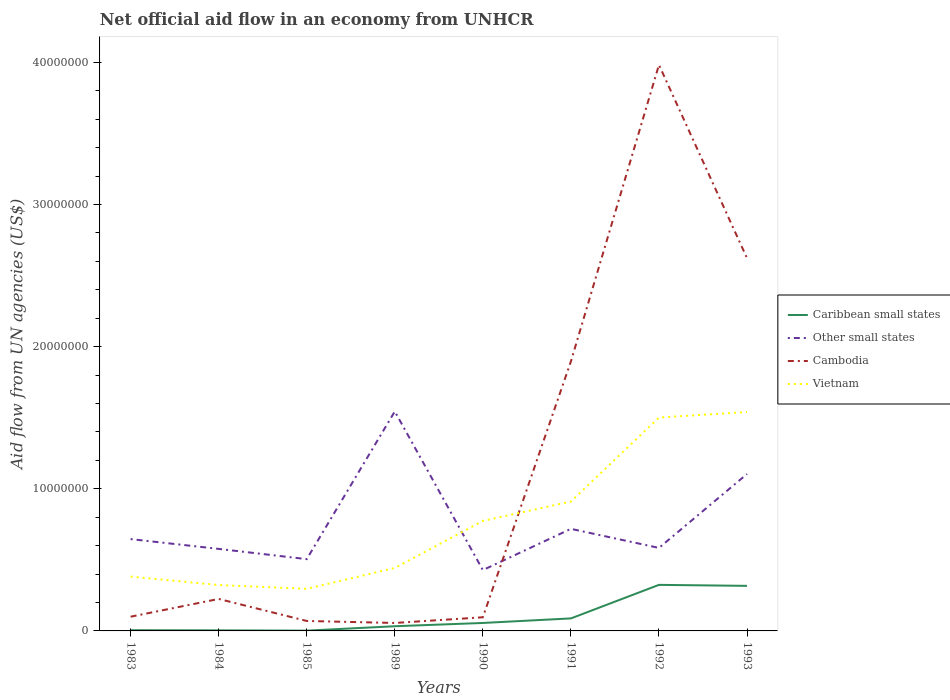In which year was the net official aid flow in Caribbean small states maximum?
Provide a short and direct response. 1985. What is the difference between the highest and the second highest net official aid flow in Vietnam?
Offer a very short reply. 1.24e+07. What is the difference between the highest and the lowest net official aid flow in Other small states?
Offer a very short reply. 2. Is the net official aid flow in Other small states strictly greater than the net official aid flow in Cambodia over the years?
Give a very brief answer. No. How many years are there in the graph?
Offer a terse response. 8. Does the graph contain grids?
Provide a succinct answer. No. What is the title of the graph?
Keep it short and to the point. Net official aid flow in an economy from UNHCR. What is the label or title of the X-axis?
Ensure brevity in your answer.  Years. What is the label or title of the Y-axis?
Offer a very short reply. Aid flow from UN agencies (US$). What is the Aid flow from UN agencies (US$) of Other small states in 1983?
Ensure brevity in your answer.  6.46e+06. What is the Aid flow from UN agencies (US$) in Vietnam in 1983?
Offer a terse response. 3.82e+06. What is the Aid flow from UN agencies (US$) in Other small states in 1984?
Keep it short and to the point. 5.77e+06. What is the Aid flow from UN agencies (US$) of Cambodia in 1984?
Make the answer very short. 2.25e+06. What is the Aid flow from UN agencies (US$) of Vietnam in 1984?
Make the answer very short. 3.23e+06. What is the Aid flow from UN agencies (US$) of Caribbean small states in 1985?
Your response must be concise. 2.00e+04. What is the Aid flow from UN agencies (US$) of Other small states in 1985?
Your answer should be compact. 5.05e+06. What is the Aid flow from UN agencies (US$) in Vietnam in 1985?
Make the answer very short. 2.96e+06. What is the Aid flow from UN agencies (US$) of Other small states in 1989?
Offer a terse response. 1.54e+07. What is the Aid flow from UN agencies (US$) of Cambodia in 1989?
Offer a terse response. 5.60e+05. What is the Aid flow from UN agencies (US$) of Vietnam in 1989?
Offer a terse response. 4.43e+06. What is the Aid flow from UN agencies (US$) of Caribbean small states in 1990?
Your response must be concise. 5.60e+05. What is the Aid flow from UN agencies (US$) in Other small states in 1990?
Keep it short and to the point. 4.28e+06. What is the Aid flow from UN agencies (US$) in Cambodia in 1990?
Offer a terse response. 9.60e+05. What is the Aid flow from UN agencies (US$) of Vietnam in 1990?
Offer a terse response. 7.74e+06. What is the Aid flow from UN agencies (US$) in Caribbean small states in 1991?
Provide a short and direct response. 8.80e+05. What is the Aid flow from UN agencies (US$) of Other small states in 1991?
Give a very brief answer. 7.18e+06. What is the Aid flow from UN agencies (US$) of Cambodia in 1991?
Ensure brevity in your answer.  1.90e+07. What is the Aid flow from UN agencies (US$) in Vietnam in 1991?
Provide a succinct answer. 9.10e+06. What is the Aid flow from UN agencies (US$) in Caribbean small states in 1992?
Offer a very short reply. 3.24e+06. What is the Aid flow from UN agencies (US$) in Other small states in 1992?
Your response must be concise. 5.84e+06. What is the Aid flow from UN agencies (US$) in Cambodia in 1992?
Your answer should be compact. 3.98e+07. What is the Aid flow from UN agencies (US$) in Vietnam in 1992?
Provide a short and direct response. 1.50e+07. What is the Aid flow from UN agencies (US$) in Caribbean small states in 1993?
Give a very brief answer. 3.17e+06. What is the Aid flow from UN agencies (US$) of Other small states in 1993?
Your answer should be very brief. 1.10e+07. What is the Aid flow from UN agencies (US$) in Cambodia in 1993?
Your answer should be very brief. 2.62e+07. What is the Aid flow from UN agencies (US$) in Vietnam in 1993?
Give a very brief answer. 1.54e+07. Across all years, what is the maximum Aid flow from UN agencies (US$) in Caribbean small states?
Provide a succinct answer. 3.24e+06. Across all years, what is the maximum Aid flow from UN agencies (US$) in Other small states?
Offer a terse response. 1.54e+07. Across all years, what is the maximum Aid flow from UN agencies (US$) of Cambodia?
Your response must be concise. 3.98e+07. Across all years, what is the maximum Aid flow from UN agencies (US$) of Vietnam?
Your response must be concise. 1.54e+07. Across all years, what is the minimum Aid flow from UN agencies (US$) in Other small states?
Your answer should be very brief. 4.28e+06. Across all years, what is the minimum Aid flow from UN agencies (US$) in Cambodia?
Make the answer very short. 5.60e+05. Across all years, what is the minimum Aid flow from UN agencies (US$) of Vietnam?
Offer a very short reply. 2.96e+06. What is the total Aid flow from UN agencies (US$) in Caribbean small states in the graph?
Your answer should be compact. 8.29e+06. What is the total Aid flow from UN agencies (US$) in Other small states in the graph?
Your answer should be very brief. 6.11e+07. What is the total Aid flow from UN agencies (US$) in Cambodia in the graph?
Offer a terse response. 9.05e+07. What is the total Aid flow from UN agencies (US$) in Vietnam in the graph?
Your answer should be very brief. 6.17e+07. What is the difference between the Aid flow from UN agencies (US$) in Caribbean small states in 1983 and that in 1984?
Your response must be concise. 10000. What is the difference between the Aid flow from UN agencies (US$) of Other small states in 1983 and that in 1984?
Ensure brevity in your answer.  6.90e+05. What is the difference between the Aid flow from UN agencies (US$) in Cambodia in 1983 and that in 1984?
Your answer should be compact. -1.25e+06. What is the difference between the Aid flow from UN agencies (US$) of Vietnam in 1983 and that in 1984?
Give a very brief answer. 5.90e+05. What is the difference between the Aid flow from UN agencies (US$) of Other small states in 1983 and that in 1985?
Your answer should be compact. 1.41e+06. What is the difference between the Aid flow from UN agencies (US$) of Cambodia in 1983 and that in 1985?
Offer a very short reply. 3.00e+05. What is the difference between the Aid flow from UN agencies (US$) in Vietnam in 1983 and that in 1985?
Offer a very short reply. 8.60e+05. What is the difference between the Aid flow from UN agencies (US$) of Caribbean small states in 1983 and that in 1989?
Make the answer very short. -2.80e+05. What is the difference between the Aid flow from UN agencies (US$) in Other small states in 1983 and that in 1989?
Provide a short and direct response. -8.98e+06. What is the difference between the Aid flow from UN agencies (US$) of Cambodia in 1983 and that in 1989?
Provide a short and direct response. 4.40e+05. What is the difference between the Aid flow from UN agencies (US$) in Vietnam in 1983 and that in 1989?
Offer a very short reply. -6.10e+05. What is the difference between the Aid flow from UN agencies (US$) of Caribbean small states in 1983 and that in 1990?
Keep it short and to the point. -5.10e+05. What is the difference between the Aid flow from UN agencies (US$) in Other small states in 1983 and that in 1990?
Provide a short and direct response. 2.18e+06. What is the difference between the Aid flow from UN agencies (US$) in Cambodia in 1983 and that in 1990?
Provide a succinct answer. 4.00e+04. What is the difference between the Aid flow from UN agencies (US$) of Vietnam in 1983 and that in 1990?
Ensure brevity in your answer.  -3.92e+06. What is the difference between the Aid flow from UN agencies (US$) in Caribbean small states in 1983 and that in 1991?
Your response must be concise. -8.30e+05. What is the difference between the Aid flow from UN agencies (US$) in Other small states in 1983 and that in 1991?
Offer a very short reply. -7.20e+05. What is the difference between the Aid flow from UN agencies (US$) of Cambodia in 1983 and that in 1991?
Provide a succinct answer. -1.80e+07. What is the difference between the Aid flow from UN agencies (US$) in Vietnam in 1983 and that in 1991?
Make the answer very short. -5.28e+06. What is the difference between the Aid flow from UN agencies (US$) of Caribbean small states in 1983 and that in 1992?
Provide a short and direct response. -3.19e+06. What is the difference between the Aid flow from UN agencies (US$) in Other small states in 1983 and that in 1992?
Ensure brevity in your answer.  6.20e+05. What is the difference between the Aid flow from UN agencies (US$) in Cambodia in 1983 and that in 1992?
Offer a terse response. -3.88e+07. What is the difference between the Aid flow from UN agencies (US$) in Vietnam in 1983 and that in 1992?
Keep it short and to the point. -1.12e+07. What is the difference between the Aid flow from UN agencies (US$) in Caribbean small states in 1983 and that in 1993?
Offer a very short reply. -3.12e+06. What is the difference between the Aid flow from UN agencies (US$) of Other small states in 1983 and that in 1993?
Make the answer very short. -4.58e+06. What is the difference between the Aid flow from UN agencies (US$) of Cambodia in 1983 and that in 1993?
Make the answer very short. -2.52e+07. What is the difference between the Aid flow from UN agencies (US$) in Vietnam in 1983 and that in 1993?
Give a very brief answer. -1.16e+07. What is the difference between the Aid flow from UN agencies (US$) in Caribbean small states in 1984 and that in 1985?
Offer a very short reply. 2.00e+04. What is the difference between the Aid flow from UN agencies (US$) in Other small states in 1984 and that in 1985?
Offer a very short reply. 7.20e+05. What is the difference between the Aid flow from UN agencies (US$) of Cambodia in 1984 and that in 1985?
Your answer should be very brief. 1.55e+06. What is the difference between the Aid flow from UN agencies (US$) in Caribbean small states in 1984 and that in 1989?
Offer a terse response. -2.90e+05. What is the difference between the Aid flow from UN agencies (US$) in Other small states in 1984 and that in 1989?
Ensure brevity in your answer.  -9.67e+06. What is the difference between the Aid flow from UN agencies (US$) in Cambodia in 1984 and that in 1989?
Make the answer very short. 1.69e+06. What is the difference between the Aid flow from UN agencies (US$) in Vietnam in 1984 and that in 1989?
Your response must be concise. -1.20e+06. What is the difference between the Aid flow from UN agencies (US$) in Caribbean small states in 1984 and that in 1990?
Keep it short and to the point. -5.20e+05. What is the difference between the Aid flow from UN agencies (US$) of Other small states in 1984 and that in 1990?
Your answer should be very brief. 1.49e+06. What is the difference between the Aid flow from UN agencies (US$) in Cambodia in 1984 and that in 1990?
Provide a succinct answer. 1.29e+06. What is the difference between the Aid flow from UN agencies (US$) of Vietnam in 1984 and that in 1990?
Your answer should be very brief. -4.51e+06. What is the difference between the Aid flow from UN agencies (US$) of Caribbean small states in 1984 and that in 1991?
Keep it short and to the point. -8.40e+05. What is the difference between the Aid flow from UN agencies (US$) in Other small states in 1984 and that in 1991?
Keep it short and to the point. -1.41e+06. What is the difference between the Aid flow from UN agencies (US$) of Cambodia in 1984 and that in 1991?
Your response must be concise. -1.67e+07. What is the difference between the Aid flow from UN agencies (US$) in Vietnam in 1984 and that in 1991?
Provide a succinct answer. -5.87e+06. What is the difference between the Aid flow from UN agencies (US$) of Caribbean small states in 1984 and that in 1992?
Your answer should be very brief. -3.20e+06. What is the difference between the Aid flow from UN agencies (US$) of Other small states in 1984 and that in 1992?
Your answer should be very brief. -7.00e+04. What is the difference between the Aid flow from UN agencies (US$) of Cambodia in 1984 and that in 1992?
Your answer should be very brief. -3.76e+07. What is the difference between the Aid flow from UN agencies (US$) of Vietnam in 1984 and that in 1992?
Offer a terse response. -1.18e+07. What is the difference between the Aid flow from UN agencies (US$) in Caribbean small states in 1984 and that in 1993?
Your answer should be compact. -3.13e+06. What is the difference between the Aid flow from UN agencies (US$) of Other small states in 1984 and that in 1993?
Keep it short and to the point. -5.27e+06. What is the difference between the Aid flow from UN agencies (US$) in Cambodia in 1984 and that in 1993?
Provide a short and direct response. -2.40e+07. What is the difference between the Aid flow from UN agencies (US$) of Vietnam in 1984 and that in 1993?
Give a very brief answer. -1.22e+07. What is the difference between the Aid flow from UN agencies (US$) in Caribbean small states in 1985 and that in 1989?
Provide a short and direct response. -3.10e+05. What is the difference between the Aid flow from UN agencies (US$) in Other small states in 1985 and that in 1989?
Provide a succinct answer. -1.04e+07. What is the difference between the Aid flow from UN agencies (US$) in Vietnam in 1985 and that in 1989?
Provide a short and direct response. -1.47e+06. What is the difference between the Aid flow from UN agencies (US$) of Caribbean small states in 1985 and that in 1990?
Give a very brief answer. -5.40e+05. What is the difference between the Aid flow from UN agencies (US$) in Other small states in 1985 and that in 1990?
Offer a terse response. 7.70e+05. What is the difference between the Aid flow from UN agencies (US$) in Cambodia in 1985 and that in 1990?
Keep it short and to the point. -2.60e+05. What is the difference between the Aid flow from UN agencies (US$) in Vietnam in 1985 and that in 1990?
Keep it short and to the point. -4.78e+06. What is the difference between the Aid flow from UN agencies (US$) in Caribbean small states in 1985 and that in 1991?
Your answer should be very brief. -8.60e+05. What is the difference between the Aid flow from UN agencies (US$) in Other small states in 1985 and that in 1991?
Your response must be concise. -2.13e+06. What is the difference between the Aid flow from UN agencies (US$) of Cambodia in 1985 and that in 1991?
Make the answer very short. -1.83e+07. What is the difference between the Aid flow from UN agencies (US$) in Vietnam in 1985 and that in 1991?
Your answer should be compact. -6.14e+06. What is the difference between the Aid flow from UN agencies (US$) in Caribbean small states in 1985 and that in 1992?
Provide a succinct answer. -3.22e+06. What is the difference between the Aid flow from UN agencies (US$) in Other small states in 1985 and that in 1992?
Keep it short and to the point. -7.90e+05. What is the difference between the Aid flow from UN agencies (US$) of Cambodia in 1985 and that in 1992?
Offer a very short reply. -3.91e+07. What is the difference between the Aid flow from UN agencies (US$) of Vietnam in 1985 and that in 1992?
Your response must be concise. -1.20e+07. What is the difference between the Aid flow from UN agencies (US$) of Caribbean small states in 1985 and that in 1993?
Make the answer very short. -3.15e+06. What is the difference between the Aid flow from UN agencies (US$) in Other small states in 1985 and that in 1993?
Provide a short and direct response. -5.99e+06. What is the difference between the Aid flow from UN agencies (US$) of Cambodia in 1985 and that in 1993?
Give a very brief answer. -2.55e+07. What is the difference between the Aid flow from UN agencies (US$) in Vietnam in 1985 and that in 1993?
Ensure brevity in your answer.  -1.24e+07. What is the difference between the Aid flow from UN agencies (US$) in Other small states in 1989 and that in 1990?
Make the answer very short. 1.12e+07. What is the difference between the Aid flow from UN agencies (US$) in Cambodia in 1989 and that in 1990?
Your answer should be compact. -4.00e+05. What is the difference between the Aid flow from UN agencies (US$) of Vietnam in 1989 and that in 1990?
Make the answer very short. -3.31e+06. What is the difference between the Aid flow from UN agencies (US$) in Caribbean small states in 1989 and that in 1991?
Your answer should be compact. -5.50e+05. What is the difference between the Aid flow from UN agencies (US$) in Other small states in 1989 and that in 1991?
Offer a terse response. 8.26e+06. What is the difference between the Aid flow from UN agencies (US$) in Cambodia in 1989 and that in 1991?
Keep it short and to the point. -1.84e+07. What is the difference between the Aid flow from UN agencies (US$) of Vietnam in 1989 and that in 1991?
Provide a succinct answer. -4.67e+06. What is the difference between the Aid flow from UN agencies (US$) of Caribbean small states in 1989 and that in 1992?
Ensure brevity in your answer.  -2.91e+06. What is the difference between the Aid flow from UN agencies (US$) in Other small states in 1989 and that in 1992?
Provide a succinct answer. 9.60e+06. What is the difference between the Aid flow from UN agencies (US$) of Cambodia in 1989 and that in 1992?
Offer a terse response. -3.93e+07. What is the difference between the Aid flow from UN agencies (US$) of Vietnam in 1989 and that in 1992?
Your response must be concise. -1.06e+07. What is the difference between the Aid flow from UN agencies (US$) in Caribbean small states in 1989 and that in 1993?
Make the answer very short. -2.84e+06. What is the difference between the Aid flow from UN agencies (US$) in Other small states in 1989 and that in 1993?
Keep it short and to the point. 4.40e+06. What is the difference between the Aid flow from UN agencies (US$) in Cambodia in 1989 and that in 1993?
Your response must be concise. -2.57e+07. What is the difference between the Aid flow from UN agencies (US$) in Vietnam in 1989 and that in 1993?
Keep it short and to the point. -1.10e+07. What is the difference between the Aid flow from UN agencies (US$) of Caribbean small states in 1990 and that in 1991?
Offer a terse response. -3.20e+05. What is the difference between the Aid flow from UN agencies (US$) in Other small states in 1990 and that in 1991?
Your answer should be compact. -2.90e+06. What is the difference between the Aid flow from UN agencies (US$) in Cambodia in 1990 and that in 1991?
Offer a terse response. -1.80e+07. What is the difference between the Aid flow from UN agencies (US$) in Vietnam in 1990 and that in 1991?
Provide a succinct answer. -1.36e+06. What is the difference between the Aid flow from UN agencies (US$) of Caribbean small states in 1990 and that in 1992?
Ensure brevity in your answer.  -2.68e+06. What is the difference between the Aid flow from UN agencies (US$) of Other small states in 1990 and that in 1992?
Ensure brevity in your answer.  -1.56e+06. What is the difference between the Aid flow from UN agencies (US$) in Cambodia in 1990 and that in 1992?
Make the answer very short. -3.89e+07. What is the difference between the Aid flow from UN agencies (US$) in Vietnam in 1990 and that in 1992?
Your answer should be compact. -7.27e+06. What is the difference between the Aid flow from UN agencies (US$) in Caribbean small states in 1990 and that in 1993?
Your answer should be very brief. -2.61e+06. What is the difference between the Aid flow from UN agencies (US$) in Other small states in 1990 and that in 1993?
Keep it short and to the point. -6.76e+06. What is the difference between the Aid flow from UN agencies (US$) of Cambodia in 1990 and that in 1993?
Offer a very short reply. -2.53e+07. What is the difference between the Aid flow from UN agencies (US$) of Vietnam in 1990 and that in 1993?
Keep it short and to the point. -7.66e+06. What is the difference between the Aid flow from UN agencies (US$) of Caribbean small states in 1991 and that in 1992?
Your answer should be very brief. -2.36e+06. What is the difference between the Aid flow from UN agencies (US$) of Other small states in 1991 and that in 1992?
Your answer should be very brief. 1.34e+06. What is the difference between the Aid flow from UN agencies (US$) of Cambodia in 1991 and that in 1992?
Offer a very short reply. -2.09e+07. What is the difference between the Aid flow from UN agencies (US$) of Vietnam in 1991 and that in 1992?
Provide a short and direct response. -5.91e+06. What is the difference between the Aid flow from UN agencies (US$) in Caribbean small states in 1991 and that in 1993?
Provide a succinct answer. -2.29e+06. What is the difference between the Aid flow from UN agencies (US$) in Other small states in 1991 and that in 1993?
Keep it short and to the point. -3.86e+06. What is the difference between the Aid flow from UN agencies (US$) in Cambodia in 1991 and that in 1993?
Provide a short and direct response. -7.26e+06. What is the difference between the Aid flow from UN agencies (US$) of Vietnam in 1991 and that in 1993?
Your answer should be compact. -6.30e+06. What is the difference between the Aid flow from UN agencies (US$) of Other small states in 1992 and that in 1993?
Make the answer very short. -5.20e+06. What is the difference between the Aid flow from UN agencies (US$) of Cambodia in 1992 and that in 1993?
Ensure brevity in your answer.  1.36e+07. What is the difference between the Aid flow from UN agencies (US$) in Vietnam in 1992 and that in 1993?
Make the answer very short. -3.90e+05. What is the difference between the Aid flow from UN agencies (US$) of Caribbean small states in 1983 and the Aid flow from UN agencies (US$) of Other small states in 1984?
Offer a very short reply. -5.72e+06. What is the difference between the Aid flow from UN agencies (US$) in Caribbean small states in 1983 and the Aid flow from UN agencies (US$) in Cambodia in 1984?
Give a very brief answer. -2.20e+06. What is the difference between the Aid flow from UN agencies (US$) of Caribbean small states in 1983 and the Aid flow from UN agencies (US$) of Vietnam in 1984?
Your answer should be compact. -3.18e+06. What is the difference between the Aid flow from UN agencies (US$) of Other small states in 1983 and the Aid flow from UN agencies (US$) of Cambodia in 1984?
Your answer should be compact. 4.21e+06. What is the difference between the Aid flow from UN agencies (US$) of Other small states in 1983 and the Aid flow from UN agencies (US$) of Vietnam in 1984?
Keep it short and to the point. 3.23e+06. What is the difference between the Aid flow from UN agencies (US$) in Cambodia in 1983 and the Aid flow from UN agencies (US$) in Vietnam in 1984?
Provide a succinct answer. -2.23e+06. What is the difference between the Aid flow from UN agencies (US$) in Caribbean small states in 1983 and the Aid flow from UN agencies (US$) in Other small states in 1985?
Your answer should be compact. -5.00e+06. What is the difference between the Aid flow from UN agencies (US$) of Caribbean small states in 1983 and the Aid flow from UN agencies (US$) of Cambodia in 1985?
Make the answer very short. -6.50e+05. What is the difference between the Aid flow from UN agencies (US$) in Caribbean small states in 1983 and the Aid flow from UN agencies (US$) in Vietnam in 1985?
Offer a very short reply. -2.91e+06. What is the difference between the Aid flow from UN agencies (US$) of Other small states in 1983 and the Aid flow from UN agencies (US$) of Cambodia in 1985?
Keep it short and to the point. 5.76e+06. What is the difference between the Aid flow from UN agencies (US$) of Other small states in 1983 and the Aid flow from UN agencies (US$) of Vietnam in 1985?
Ensure brevity in your answer.  3.50e+06. What is the difference between the Aid flow from UN agencies (US$) of Cambodia in 1983 and the Aid flow from UN agencies (US$) of Vietnam in 1985?
Offer a terse response. -1.96e+06. What is the difference between the Aid flow from UN agencies (US$) of Caribbean small states in 1983 and the Aid flow from UN agencies (US$) of Other small states in 1989?
Give a very brief answer. -1.54e+07. What is the difference between the Aid flow from UN agencies (US$) of Caribbean small states in 1983 and the Aid flow from UN agencies (US$) of Cambodia in 1989?
Make the answer very short. -5.10e+05. What is the difference between the Aid flow from UN agencies (US$) in Caribbean small states in 1983 and the Aid flow from UN agencies (US$) in Vietnam in 1989?
Make the answer very short. -4.38e+06. What is the difference between the Aid flow from UN agencies (US$) in Other small states in 1983 and the Aid flow from UN agencies (US$) in Cambodia in 1989?
Give a very brief answer. 5.90e+06. What is the difference between the Aid flow from UN agencies (US$) in Other small states in 1983 and the Aid flow from UN agencies (US$) in Vietnam in 1989?
Give a very brief answer. 2.03e+06. What is the difference between the Aid flow from UN agencies (US$) of Cambodia in 1983 and the Aid flow from UN agencies (US$) of Vietnam in 1989?
Make the answer very short. -3.43e+06. What is the difference between the Aid flow from UN agencies (US$) of Caribbean small states in 1983 and the Aid flow from UN agencies (US$) of Other small states in 1990?
Offer a terse response. -4.23e+06. What is the difference between the Aid flow from UN agencies (US$) in Caribbean small states in 1983 and the Aid flow from UN agencies (US$) in Cambodia in 1990?
Give a very brief answer. -9.10e+05. What is the difference between the Aid flow from UN agencies (US$) in Caribbean small states in 1983 and the Aid flow from UN agencies (US$) in Vietnam in 1990?
Your answer should be very brief. -7.69e+06. What is the difference between the Aid flow from UN agencies (US$) in Other small states in 1983 and the Aid flow from UN agencies (US$) in Cambodia in 1990?
Give a very brief answer. 5.50e+06. What is the difference between the Aid flow from UN agencies (US$) of Other small states in 1983 and the Aid flow from UN agencies (US$) of Vietnam in 1990?
Give a very brief answer. -1.28e+06. What is the difference between the Aid flow from UN agencies (US$) in Cambodia in 1983 and the Aid flow from UN agencies (US$) in Vietnam in 1990?
Your answer should be very brief. -6.74e+06. What is the difference between the Aid flow from UN agencies (US$) of Caribbean small states in 1983 and the Aid flow from UN agencies (US$) of Other small states in 1991?
Offer a very short reply. -7.13e+06. What is the difference between the Aid flow from UN agencies (US$) of Caribbean small states in 1983 and the Aid flow from UN agencies (US$) of Cambodia in 1991?
Your answer should be compact. -1.89e+07. What is the difference between the Aid flow from UN agencies (US$) in Caribbean small states in 1983 and the Aid flow from UN agencies (US$) in Vietnam in 1991?
Give a very brief answer. -9.05e+06. What is the difference between the Aid flow from UN agencies (US$) in Other small states in 1983 and the Aid flow from UN agencies (US$) in Cambodia in 1991?
Make the answer very short. -1.25e+07. What is the difference between the Aid flow from UN agencies (US$) of Other small states in 1983 and the Aid flow from UN agencies (US$) of Vietnam in 1991?
Give a very brief answer. -2.64e+06. What is the difference between the Aid flow from UN agencies (US$) in Cambodia in 1983 and the Aid flow from UN agencies (US$) in Vietnam in 1991?
Ensure brevity in your answer.  -8.10e+06. What is the difference between the Aid flow from UN agencies (US$) in Caribbean small states in 1983 and the Aid flow from UN agencies (US$) in Other small states in 1992?
Offer a terse response. -5.79e+06. What is the difference between the Aid flow from UN agencies (US$) of Caribbean small states in 1983 and the Aid flow from UN agencies (US$) of Cambodia in 1992?
Give a very brief answer. -3.98e+07. What is the difference between the Aid flow from UN agencies (US$) of Caribbean small states in 1983 and the Aid flow from UN agencies (US$) of Vietnam in 1992?
Your answer should be very brief. -1.50e+07. What is the difference between the Aid flow from UN agencies (US$) in Other small states in 1983 and the Aid flow from UN agencies (US$) in Cambodia in 1992?
Offer a very short reply. -3.34e+07. What is the difference between the Aid flow from UN agencies (US$) of Other small states in 1983 and the Aid flow from UN agencies (US$) of Vietnam in 1992?
Ensure brevity in your answer.  -8.55e+06. What is the difference between the Aid flow from UN agencies (US$) in Cambodia in 1983 and the Aid flow from UN agencies (US$) in Vietnam in 1992?
Provide a succinct answer. -1.40e+07. What is the difference between the Aid flow from UN agencies (US$) of Caribbean small states in 1983 and the Aid flow from UN agencies (US$) of Other small states in 1993?
Your answer should be compact. -1.10e+07. What is the difference between the Aid flow from UN agencies (US$) in Caribbean small states in 1983 and the Aid flow from UN agencies (US$) in Cambodia in 1993?
Your answer should be very brief. -2.62e+07. What is the difference between the Aid flow from UN agencies (US$) of Caribbean small states in 1983 and the Aid flow from UN agencies (US$) of Vietnam in 1993?
Make the answer very short. -1.54e+07. What is the difference between the Aid flow from UN agencies (US$) of Other small states in 1983 and the Aid flow from UN agencies (US$) of Cambodia in 1993?
Make the answer very short. -1.98e+07. What is the difference between the Aid flow from UN agencies (US$) in Other small states in 1983 and the Aid flow from UN agencies (US$) in Vietnam in 1993?
Your response must be concise. -8.94e+06. What is the difference between the Aid flow from UN agencies (US$) of Cambodia in 1983 and the Aid flow from UN agencies (US$) of Vietnam in 1993?
Ensure brevity in your answer.  -1.44e+07. What is the difference between the Aid flow from UN agencies (US$) of Caribbean small states in 1984 and the Aid flow from UN agencies (US$) of Other small states in 1985?
Give a very brief answer. -5.01e+06. What is the difference between the Aid flow from UN agencies (US$) of Caribbean small states in 1984 and the Aid flow from UN agencies (US$) of Cambodia in 1985?
Ensure brevity in your answer.  -6.60e+05. What is the difference between the Aid flow from UN agencies (US$) of Caribbean small states in 1984 and the Aid flow from UN agencies (US$) of Vietnam in 1985?
Make the answer very short. -2.92e+06. What is the difference between the Aid flow from UN agencies (US$) in Other small states in 1984 and the Aid flow from UN agencies (US$) in Cambodia in 1985?
Keep it short and to the point. 5.07e+06. What is the difference between the Aid flow from UN agencies (US$) of Other small states in 1984 and the Aid flow from UN agencies (US$) of Vietnam in 1985?
Make the answer very short. 2.81e+06. What is the difference between the Aid flow from UN agencies (US$) of Cambodia in 1984 and the Aid flow from UN agencies (US$) of Vietnam in 1985?
Make the answer very short. -7.10e+05. What is the difference between the Aid flow from UN agencies (US$) of Caribbean small states in 1984 and the Aid flow from UN agencies (US$) of Other small states in 1989?
Make the answer very short. -1.54e+07. What is the difference between the Aid flow from UN agencies (US$) of Caribbean small states in 1984 and the Aid flow from UN agencies (US$) of Cambodia in 1989?
Your response must be concise. -5.20e+05. What is the difference between the Aid flow from UN agencies (US$) of Caribbean small states in 1984 and the Aid flow from UN agencies (US$) of Vietnam in 1989?
Your answer should be compact. -4.39e+06. What is the difference between the Aid flow from UN agencies (US$) in Other small states in 1984 and the Aid flow from UN agencies (US$) in Cambodia in 1989?
Offer a terse response. 5.21e+06. What is the difference between the Aid flow from UN agencies (US$) in Other small states in 1984 and the Aid flow from UN agencies (US$) in Vietnam in 1989?
Ensure brevity in your answer.  1.34e+06. What is the difference between the Aid flow from UN agencies (US$) of Cambodia in 1984 and the Aid flow from UN agencies (US$) of Vietnam in 1989?
Provide a succinct answer. -2.18e+06. What is the difference between the Aid flow from UN agencies (US$) of Caribbean small states in 1984 and the Aid flow from UN agencies (US$) of Other small states in 1990?
Give a very brief answer. -4.24e+06. What is the difference between the Aid flow from UN agencies (US$) of Caribbean small states in 1984 and the Aid flow from UN agencies (US$) of Cambodia in 1990?
Provide a succinct answer. -9.20e+05. What is the difference between the Aid flow from UN agencies (US$) in Caribbean small states in 1984 and the Aid flow from UN agencies (US$) in Vietnam in 1990?
Your answer should be very brief. -7.70e+06. What is the difference between the Aid flow from UN agencies (US$) of Other small states in 1984 and the Aid flow from UN agencies (US$) of Cambodia in 1990?
Your answer should be very brief. 4.81e+06. What is the difference between the Aid flow from UN agencies (US$) of Other small states in 1984 and the Aid flow from UN agencies (US$) of Vietnam in 1990?
Your answer should be very brief. -1.97e+06. What is the difference between the Aid flow from UN agencies (US$) of Cambodia in 1984 and the Aid flow from UN agencies (US$) of Vietnam in 1990?
Offer a very short reply. -5.49e+06. What is the difference between the Aid flow from UN agencies (US$) of Caribbean small states in 1984 and the Aid flow from UN agencies (US$) of Other small states in 1991?
Give a very brief answer. -7.14e+06. What is the difference between the Aid flow from UN agencies (US$) in Caribbean small states in 1984 and the Aid flow from UN agencies (US$) in Cambodia in 1991?
Your answer should be compact. -1.89e+07. What is the difference between the Aid flow from UN agencies (US$) of Caribbean small states in 1984 and the Aid flow from UN agencies (US$) of Vietnam in 1991?
Ensure brevity in your answer.  -9.06e+06. What is the difference between the Aid flow from UN agencies (US$) of Other small states in 1984 and the Aid flow from UN agencies (US$) of Cambodia in 1991?
Provide a succinct answer. -1.32e+07. What is the difference between the Aid flow from UN agencies (US$) in Other small states in 1984 and the Aid flow from UN agencies (US$) in Vietnam in 1991?
Your response must be concise. -3.33e+06. What is the difference between the Aid flow from UN agencies (US$) in Cambodia in 1984 and the Aid flow from UN agencies (US$) in Vietnam in 1991?
Provide a succinct answer. -6.85e+06. What is the difference between the Aid flow from UN agencies (US$) of Caribbean small states in 1984 and the Aid flow from UN agencies (US$) of Other small states in 1992?
Your response must be concise. -5.80e+06. What is the difference between the Aid flow from UN agencies (US$) in Caribbean small states in 1984 and the Aid flow from UN agencies (US$) in Cambodia in 1992?
Your answer should be compact. -3.98e+07. What is the difference between the Aid flow from UN agencies (US$) in Caribbean small states in 1984 and the Aid flow from UN agencies (US$) in Vietnam in 1992?
Offer a terse response. -1.50e+07. What is the difference between the Aid flow from UN agencies (US$) of Other small states in 1984 and the Aid flow from UN agencies (US$) of Cambodia in 1992?
Your answer should be very brief. -3.40e+07. What is the difference between the Aid flow from UN agencies (US$) in Other small states in 1984 and the Aid flow from UN agencies (US$) in Vietnam in 1992?
Provide a succinct answer. -9.24e+06. What is the difference between the Aid flow from UN agencies (US$) of Cambodia in 1984 and the Aid flow from UN agencies (US$) of Vietnam in 1992?
Make the answer very short. -1.28e+07. What is the difference between the Aid flow from UN agencies (US$) of Caribbean small states in 1984 and the Aid flow from UN agencies (US$) of Other small states in 1993?
Provide a succinct answer. -1.10e+07. What is the difference between the Aid flow from UN agencies (US$) in Caribbean small states in 1984 and the Aid flow from UN agencies (US$) in Cambodia in 1993?
Your answer should be very brief. -2.62e+07. What is the difference between the Aid flow from UN agencies (US$) in Caribbean small states in 1984 and the Aid flow from UN agencies (US$) in Vietnam in 1993?
Ensure brevity in your answer.  -1.54e+07. What is the difference between the Aid flow from UN agencies (US$) in Other small states in 1984 and the Aid flow from UN agencies (US$) in Cambodia in 1993?
Provide a short and direct response. -2.04e+07. What is the difference between the Aid flow from UN agencies (US$) of Other small states in 1984 and the Aid flow from UN agencies (US$) of Vietnam in 1993?
Ensure brevity in your answer.  -9.63e+06. What is the difference between the Aid flow from UN agencies (US$) in Cambodia in 1984 and the Aid flow from UN agencies (US$) in Vietnam in 1993?
Keep it short and to the point. -1.32e+07. What is the difference between the Aid flow from UN agencies (US$) of Caribbean small states in 1985 and the Aid flow from UN agencies (US$) of Other small states in 1989?
Provide a succinct answer. -1.54e+07. What is the difference between the Aid flow from UN agencies (US$) of Caribbean small states in 1985 and the Aid flow from UN agencies (US$) of Cambodia in 1989?
Keep it short and to the point. -5.40e+05. What is the difference between the Aid flow from UN agencies (US$) of Caribbean small states in 1985 and the Aid flow from UN agencies (US$) of Vietnam in 1989?
Make the answer very short. -4.41e+06. What is the difference between the Aid flow from UN agencies (US$) of Other small states in 1985 and the Aid flow from UN agencies (US$) of Cambodia in 1989?
Make the answer very short. 4.49e+06. What is the difference between the Aid flow from UN agencies (US$) in Other small states in 1985 and the Aid flow from UN agencies (US$) in Vietnam in 1989?
Your answer should be very brief. 6.20e+05. What is the difference between the Aid flow from UN agencies (US$) in Cambodia in 1985 and the Aid flow from UN agencies (US$) in Vietnam in 1989?
Your answer should be very brief. -3.73e+06. What is the difference between the Aid flow from UN agencies (US$) of Caribbean small states in 1985 and the Aid flow from UN agencies (US$) of Other small states in 1990?
Your answer should be compact. -4.26e+06. What is the difference between the Aid flow from UN agencies (US$) in Caribbean small states in 1985 and the Aid flow from UN agencies (US$) in Cambodia in 1990?
Your answer should be very brief. -9.40e+05. What is the difference between the Aid flow from UN agencies (US$) in Caribbean small states in 1985 and the Aid flow from UN agencies (US$) in Vietnam in 1990?
Provide a succinct answer. -7.72e+06. What is the difference between the Aid flow from UN agencies (US$) of Other small states in 1985 and the Aid flow from UN agencies (US$) of Cambodia in 1990?
Provide a succinct answer. 4.09e+06. What is the difference between the Aid flow from UN agencies (US$) in Other small states in 1985 and the Aid flow from UN agencies (US$) in Vietnam in 1990?
Provide a succinct answer. -2.69e+06. What is the difference between the Aid flow from UN agencies (US$) of Cambodia in 1985 and the Aid flow from UN agencies (US$) of Vietnam in 1990?
Ensure brevity in your answer.  -7.04e+06. What is the difference between the Aid flow from UN agencies (US$) in Caribbean small states in 1985 and the Aid flow from UN agencies (US$) in Other small states in 1991?
Your response must be concise. -7.16e+06. What is the difference between the Aid flow from UN agencies (US$) of Caribbean small states in 1985 and the Aid flow from UN agencies (US$) of Cambodia in 1991?
Provide a short and direct response. -1.89e+07. What is the difference between the Aid flow from UN agencies (US$) in Caribbean small states in 1985 and the Aid flow from UN agencies (US$) in Vietnam in 1991?
Provide a succinct answer. -9.08e+06. What is the difference between the Aid flow from UN agencies (US$) of Other small states in 1985 and the Aid flow from UN agencies (US$) of Cambodia in 1991?
Ensure brevity in your answer.  -1.39e+07. What is the difference between the Aid flow from UN agencies (US$) in Other small states in 1985 and the Aid flow from UN agencies (US$) in Vietnam in 1991?
Your answer should be compact. -4.05e+06. What is the difference between the Aid flow from UN agencies (US$) in Cambodia in 1985 and the Aid flow from UN agencies (US$) in Vietnam in 1991?
Give a very brief answer. -8.40e+06. What is the difference between the Aid flow from UN agencies (US$) of Caribbean small states in 1985 and the Aid flow from UN agencies (US$) of Other small states in 1992?
Keep it short and to the point. -5.82e+06. What is the difference between the Aid flow from UN agencies (US$) of Caribbean small states in 1985 and the Aid flow from UN agencies (US$) of Cambodia in 1992?
Your answer should be very brief. -3.98e+07. What is the difference between the Aid flow from UN agencies (US$) of Caribbean small states in 1985 and the Aid flow from UN agencies (US$) of Vietnam in 1992?
Your answer should be very brief. -1.50e+07. What is the difference between the Aid flow from UN agencies (US$) in Other small states in 1985 and the Aid flow from UN agencies (US$) in Cambodia in 1992?
Offer a terse response. -3.48e+07. What is the difference between the Aid flow from UN agencies (US$) of Other small states in 1985 and the Aid flow from UN agencies (US$) of Vietnam in 1992?
Give a very brief answer. -9.96e+06. What is the difference between the Aid flow from UN agencies (US$) in Cambodia in 1985 and the Aid flow from UN agencies (US$) in Vietnam in 1992?
Your answer should be compact. -1.43e+07. What is the difference between the Aid flow from UN agencies (US$) of Caribbean small states in 1985 and the Aid flow from UN agencies (US$) of Other small states in 1993?
Offer a very short reply. -1.10e+07. What is the difference between the Aid flow from UN agencies (US$) of Caribbean small states in 1985 and the Aid flow from UN agencies (US$) of Cambodia in 1993?
Provide a short and direct response. -2.62e+07. What is the difference between the Aid flow from UN agencies (US$) in Caribbean small states in 1985 and the Aid flow from UN agencies (US$) in Vietnam in 1993?
Offer a terse response. -1.54e+07. What is the difference between the Aid flow from UN agencies (US$) of Other small states in 1985 and the Aid flow from UN agencies (US$) of Cambodia in 1993?
Your answer should be compact. -2.12e+07. What is the difference between the Aid flow from UN agencies (US$) in Other small states in 1985 and the Aid flow from UN agencies (US$) in Vietnam in 1993?
Your answer should be very brief. -1.04e+07. What is the difference between the Aid flow from UN agencies (US$) of Cambodia in 1985 and the Aid flow from UN agencies (US$) of Vietnam in 1993?
Your answer should be very brief. -1.47e+07. What is the difference between the Aid flow from UN agencies (US$) of Caribbean small states in 1989 and the Aid flow from UN agencies (US$) of Other small states in 1990?
Keep it short and to the point. -3.95e+06. What is the difference between the Aid flow from UN agencies (US$) of Caribbean small states in 1989 and the Aid flow from UN agencies (US$) of Cambodia in 1990?
Provide a succinct answer. -6.30e+05. What is the difference between the Aid flow from UN agencies (US$) of Caribbean small states in 1989 and the Aid flow from UN agencies (US$) of Vietnam in 1990?
Your answer should be compact. -7.41e+06. What is the difference between the Aid flow from UN agencies (US$) in Other small states in 1989 and the Aid flow from UN agencies (US$) in Cambodia in 1990?
Keep it short and to the point. 1.45e+07. What is the difference between the Aid flow from UN agencies (US$) in Other small states in 1989 and the Aid flow from UN agencies (US$) in Vietnam in 1990?
Give a very brief answer. 7.70e+06. What is the difference between the Aid flow from UN agencies (US$) of Cambodia in 1989 and the Aid flow from UN agencies (US$) of Vietnam in 1990?
Provide a succinct answer. -7.18e+06. What is the difference between the Aid flow from UN agencies (US$) of Caribbean small states in 1989 and the Aid flow from UN agencies (US$) of Other small states in 1991?
Provide a short and direct response. -6.85e+06. What is the difference between the Aid flow from UN agencies (US$) of Caribbean small states in 1989 and the Aid flow from UN agencies (US$) of Cambodia in 1991?
Give a very brief answer. -1.86e+07. What is the difference between the Aid flow from UN agencies (US$) of Caribbean small states in 1989 and the Aid flow from UN agencies (US$) of Vietnam in 1991?
Keep it short and to the point. -8.77e+06. What is the difference between the Aid flow from UN agencies (US$) of Other small states in 1989 and the Aid flow from UN agencies (US$) of Cambodia in 1991?
Your answer should be very brief. -3.52e+06. What is the difference between the Aid flow from UN agencies (US$) in Other small states in 1989 and the Aid flow from UN agencies (US$) in Vietnam in 1991?
Your response must be concise. 6.34e+06. What is the difference between the Aid flow from UN agencies (US$) of Cambodia in 1989 and the Aid flow from UN agencies (US$) of Vietnam in 1991?
Ensure brevity in your answer.  -8.54e+06. What is the difference between the Aid flow from UN agencies (US$) in Caribbean small states in 1989 and the Aid flow from UN agencies (US$) in Other small states in 1992?
Provide a short and direct response. -5.51e+06. What is the difference between the Aid flow from UN agencies (US$) of Caribbean small states in 1989 and the Aid flow from UN agencies (US$) of Cambodia in 1992?
Keep it short and to the point. -3.95e+07. What is the difference between the Aid flow from UN agencies (US$) in Caribbean small states in 1989 and the Aid flow from UN agencies (US$) in Vietnam in 1992?
Offer a very short reply. -1.47e+07. What is the difference between the Aid flow from UN agencies (US$) in Other small states in 1989 and the Aid flow from UN agencies (US$) in Cambodia in 1992?
Your answer should be compact. -2.44e+07. What is the difference between the Aid flow from UN agencies (US$) of Cambodia in 1989 and the Aid flow from UN agencies (US$) of Vietnam in 1992?
Your answer should be very brief. -1.44e+07. What is the difference between the Aid flow from UN agencies (US$) of Caribbean small states in 1989 and the Aid flow from UN agencies (US$) of Other small states in 1993?
Your answer should be compact. -1.07e+07. What is the difference between the Aid flow from UN agencies (US$) in Caribbean small states in 1989 and the Aid flow from UN agencies (US$) in Cambodia in 1993?
Your answer should be compact. -2.59e+07. What is the difference between the Aid flow from UN agencies (US$) in Caribbean small states in 1989 and the Aid flow from UN agencies (US$) in Vietnam in 1993?
Give a very brief answer. -1.51e+07. What is the difference between the Aid flow from UN agencies (US$) in Other small states in 1989 and the Aid flow from UN agencies (US$) in Cambodia in 1993?
Your answer should be very brief. -1.08e+07. What is the difference between the Aid flow from UN agencies (US$) in Cambodia in 1989 and the Aid flow from UN agencies (US$) in Vietnam in 1993?
Provide a succinct answer. -1.48e+07. What is the difference between the Aid flow from UN agencies (US$) of Caribbean small states in 1990 and the Aid flow from UN agencies (US$) of Other small states in 1991?
Your response must be concise. -6.62e+06. What is the difference between the Aid flow from UN agencies (US$) in Caribbean small states in 1990 and the Aid flow from UN agencies (US$) in Cambodia in 1991?
Keep it short and to the point. -1.84e+07. What is the difference between the Aid flow from UN agencies (US$) in Caribbean small states in 1990 and the Aid flow from UN agencies (US$) in Vietnam in 1991?
Offer a terse response. -8.54e+06. What is the difference between the Aid flow from UN agencies (US$) in Other small states in 1990 and the Aid flow from UN agencies (US$) in Cambodia in 1991?
Give a very brief answer. -1.47e+07. What is the difference between the Aid flow from UN agencies (US$) of Other small states in 1990 and the Aid flow from UN agencies (US$) of Vietnam in 1991?
Offer a terse response. -4.82e+06. What is the difference between the Aid flow from UN agencies (US$) of Cambodia in 1990 and the Aid flow from UN agencies (US$) of Vietnam in 1991?
Give a very brief answer. -8.14e+06. What is the difference between the Aid flow from UN agencies (US$) of Caribbean small states in 1990 and the Aid flow from UN agencies (US$) of Other small states in 1992?
Offer a very short reply. -5.28e+06. What is the difference between the Aid flow from UN agencies (US$) in Caribbean small states in 1990 and the Aid flow from UN agencies (US$) in Cambodia in 1992?
Your response must be concise. -3.93e+07. What is the difference between the Aid flow from UN agencies (US$) of Caribbean small states in 1990 and the Aid flow from UN agencies (US$) of Vietnam in 1992?
Your answer should be compact. -1.44e+07. What is the difference between the Aid flow from UN agencies (US$) of Other small states in 1990 and the Aid flow from UN agencies (US$) of Cambodia in 1992?
Keep it short and to the point. -3.55e+07. What is the difference between the Aid flow from UN agencies (US$) in Other small states in 1990 and the Aid flow from UN agencies (US$) in Vietnam in 1992?
Your response must be concise. -1.07e+07. What is the difference between the Aid flow from UN agencies (US$) in Cambodia in 1990 and the Aid flow from UN agencies (US$) in Vietnam in 1992?
Give a very brief answer. -1.40e+07. What is the difference between the Aid flow from UN agencies (US$) in Caribbean small states in 1990 and the Aid flow from UN agencies (US$) in Other small states in 1993?
Make the answer very short. -1.05e+07. What is the difference between the Aid flow from UN agencies (US$) of Caribbean small states in 1990 and the Aid flow from UN agencies (US$) of Cambodia in 1993?
Offer a terse response. -2.57e+07. What is the difference between the Aid flow from UN agencies (US$) of Caribbean small states in 1990 and the Aid flow from UN agencies (US$) of Vietnam in 1993?
Make the answer very short. -1.48e+07. What is the difference between the Aid flow from UN agencies (US$) of Other small states in 1990 and the Aid flow from UN agencies (US$) of Cambodia in 1993?
Your answer should be compact. -2.19e+07. What is the difference between the Aid flow from UN agencies (US$) of Other small states in 1990 and the Aid flow from UN agencies (US$) of Vietnam in 1993?
Provide a short and direct response. -1.11e+07. What is the difference between the Aid flow from UN agencies (US$) of Cambodia in 1990 and the Aid flow from UN agencies (US$) of Vietnam in 1993?
Your response must be concise. -1.44e+07. What is the difference between the Aid flow from UN agencies (US$) of Caribbean small states in 1991 and the Aid flow from UN agencies (US$) of Other small states in 1992?
Offer a terse response. -4.96e+06. What is the difference between the Aid flow from UN agencies (US$) of Caribbean small states in 1991 and the Aid flow from UN agencies (US$) of Cambodia in 1992?
Make the answer very short. -3.89e+07. What is the difference between the Aid flow from UN agencies (US$) of Caribbean small states in 1991 and the Aid flow from UN agencies (US$) of Vietnam in 1992?
Ensure brevity in your answer.  -1.41e+07. What is the difference between the Aid flow from UN agencies (US$) in Other small states in 1991 and the Aid flow from UN agencies (US$) in Cambodia in 1992?
Your answer should be very brief. -3.26e+07. What is the difference between the Aid flow from UN agencies (US$) in Other small states in 1991 and the Aid flow from UN agencies (US$) in Vietnam in 1992?
Make the answer very short. -7.83e+06. What is the difference between the Aid flow from UN agencies (US$) in Cambodia in 1991 and the Aid flow from UN agencies (US$) in Vietnam in 1992?
Your answer should be very brief. 3.95e+06. What is the difference between the Aid flow from UN agencies (US$) in Caribbean small states in 1991 and the Aid flow from UN agencies (US$) in Other small states in 1993?
Your response must be concise. -1.02e+07. What is the difference between the Aid flow from UN agencies (US$) in Caribbean small states in 1991 and the Aid flow from UN agencies (US$) in Cambodia in 1993?
Provide a succinct answer. -2.53e+07. What is the difference between the Aid flow from UN agencies (US$) in Caribbean small states in 1991 and the Aid flow from UN agencies (US$) in Vietnam in 1993?
Provide a succinct answer. -1.45e+07. What is the difference between the Aid flow from UN agencies (US$) of Other small states in 1991 and the Aid flow from UN agencies (US$) of Cambodia in 1993?
Provide a succinct answer. -1.90e+07. What is the difference between the Aid flow from UN agencies (US$) in Other small states in 1991 and the Aid flow from UN agencies (US$) in Vietnam in 1993?
Provide a short and direct response. -8.22e+06. What is the difference between the Aid flow from UN agencies (US$) in Cambodia in 1991 and the Aid flow from UN agencies (US$) in Vietnam in 1993?
Keep it short and to the point. 3.56e+06. What is the difference between the Aid flow from UN agencies (US$) of Caribbean small states in 1992 and the Aid flow from UN agencies (US$) of Other small states in 1993?
Ensure brevity in your answer.  -7.80e+06. What is the difference between the Aid flow from UN agencies (US$) of Caribbean small states in 1992 and the Aid flow from UN agencies (US$) of Cambodia in 1993?
Your answer should be compact. -2.30e+07. What is the difference between the Aid flow from UN agencies (US$) of Caribbean small states in 1992 and the Aid flow from UN agencies (US$) of Vietnam in 1993?
Your response must be concise. -1.22e+07. What is the difference between the Aid flow from UN agencies (US$) of Other small states in 1992 and the Aid flow from UN agencies (US$) of Cambodia in 1993?
Give a very brief answer. -2.04e+07. What is the difference between the Aid flow from UN agencies (US$) of Other small states in 1992 and the Aid flow from UN agencies (US$) of Vietnam in 1993?
Make the answer very short. -9.56e+06. What is the difference between the Aid flow from UN agencies (US$) in Cambodia in 1992 and the Aid flow from UN agencies (US$) in Vietnam in 1993?
Ensure brevity in your answer.  2.44e+07. What is the average Aid flow from UN agencies (US$) in Caribbean small states per year?
Give a very brief answer. 1.04e+06. What is the average Aid flow from UN agencies (US$) in Other small states per year?
Keep it short and to the point. 7.63e+06. What is the average Aid flow from UN agencies (US$) of Cambodia per year?
Give a very brief answer. 1.13e+07. What is the average Aid flow from UN agencies (US$) in Vietnam per year?
Keep it short and to the point. 7.71e+06. In the year 1983, what is the difference between the Aid flow from UN agencies (US$) in Caribbean small states and Aid flow from UN agencies (US$) in Other small states?
Offer a terse response. -6.41e+06. In the year 1983, what is the difference between the Aid flow from UN agencies (US$) of Caribbean small states and Aid flow from UN agencies (US$) of Cambodia?
Give a very brief answer. -9.50e+05. In the year 1983, what is the difference between the Aid flow from UN agencies (US$) in Caribbean small states and Aid flow from UN agencies (US$) in Vietnam?
Your answer should be compact. -3.77e+06. In the year 1983, what is the difference between the Aid flow from UN agencies (US$) in Other small states and Aid flow from UN agencies (US$) in Cambodia?
Keep it short and to the point. 5.46e+06. In the year 1983, what is the difference between the Aid flow from UN agencies (US$) in Other small states and Aid flow from UN agencies (US$) in Vietnam?
Your answer should be very brief. 2.64e+06. In the year 1983, what is the difference between the Aid flow from UN agencies (US$) in Cambodia and Aid flow from UN agencies (US$) in Vietnam?
Make the answer very short. -2.82e+06. In the year 1984, what is the difference between the Aid flow from UN agencies (US$) in Caribbean small states and Aid flow from UN agencies (US$) in Other small states?
Offer a terse response. -5.73e+06. In the year 1984, what is the difference between the Aid flow from UN agencies (US$) of Caribbean small states and Aid flow from UN agencies (US$) of Cambodia?
Offer a very short reply. -2.21e+06. In the year 1984, what is the difference between the Aid flow from UN agencies (US$) of Caribbean small states and Aid flow from UN agencies (US$) of Vietnam?
Offer a terse response. -3.19e+06. In the year 1984, what is the difference between the Aid flow from UN agencies (US$) of Other small states and Aid flow from UN agencies (US$) of Cambodia?
Give a very brief answer. 3.52e+06. In the year 1984, what is the difference between the Aid flow from UN agencies (US$) in Other small states and Aid flow from UN agencies (US$) in Vietnam?
Give a very brief answer. 2.54e+06. In the year 1984, what is the difference between the Aid flow from UN agencies (US$) of Cambodia and Aid flow from UN agencies (US$) of Vietnam?
Offer a very short reply. -9.80e+05. In the year 1985, what is the difference between the Aid flow from UN agencies (US$) in Caribbean small states and Aid flow from UN agencies (US$) in Other small states?
Offer a very short reply. -5.03e+06. In the year 1985, what is the difference between the Aid flow from UN agencies (US$) in Caribbean small states and Aid flow from UN agencies (US$) in Cambodia?
Offer a very short reply. -6.80e+05. In the year 1985, what is the difference between the Aid flow from UN agencies (US$) of Caribbean small states and Aid flow from UN agencies (US$) of Vietnam?
Your answer should be very brief. -2.94e+06. In the year 1985, what is the difference between the Aid flow from UN agencies (US$) of Other small states and Aid flow from UN agencies (US$) of Cambodia?
Your answer should be very brief. 4.35e+06. In the year 1985, what is the difference between the Aid flow from UN agencies (US$) in Other small states and Aid flow from UN agencies (US$) in Vietnam?
Offer a terse response. 2.09e+06. In the year 1985, what is the difference between the Aid flow from UN agencies (US$) in Cambodia and Aid flow from UN agencies (US$) in Vietnam?
Make the answer very short. -2.26e+06. In the year 1989, what is the difference between the Aid flow from UN agencies (US$) in Caribbean small states and Aid flow from UN agencies (US$) in Other small states?
Offer a terse response. -1.51e+07. In the year 1989, what is the difference between the Aid flow from UN agencies (US$) in Caribbean small states and Aid flow from UN agencies (US$) in Cambodia?
Provide a succinct answer. -2.30e+05. In the year 1989, what is the difference between the Aid flow from UN agencies (US$) in Caribbean small states and Aid flow from UN agencies (US$) in Vietnam?
Give a very brief answer. -4.10e+06. In the year 1989, what is the difference between the Aid flow from UN agencies (US$) in Other small states and Aid flow from UN agencies (US$) in Cambodia?
Ensure brevity in your answer.  1.49e+07. In the year 1989, what is the difference between the Aid flow from UN agencies (US$) in Other small states and Aid flow from UN agencies (US$) in Vietnam?
Provide a short and direct response. 1.10e+07. In the year 1989, what is the difference between the Aid flow from UN agencies (US$) in Cambodia and Aid flow from UN agencies (US$) in Vietnam?
Provide a succinct answer. -3.87e+06. In the year 1990, what is the difference between the Aid flow from UN agencies (US$) in Caribbean small states and Aid flow from UN agencies (US$) in Other small states?
Keep it short and to the point. -3.72e+06. In the year 1990, what is the difference between the Aid flow from UN agencies (US$) of Caribbean small states and Aid flow from UN agencies (US$) of Cambodia?
Offer a terse response. -4.00e+05. In the year 1990, what is the difference between the Aid flow from UN agencies (US$) in Caribbean small states and Aid flow from UN agencies (US$) in Vietnam?
Give a very brief answer. -7.18e+06. In the year 1990, what is the difference between the Aid flow from UN agencies (US$) in Other small states and Aid flow from UN agencies (US$) in Cambodia?
Offer a very short reply. 3.32e+06. In the year 1990, what is the difference between the Aid flow from UN agencies (US$) of Other small states and Aid flow from UN agencies (US$) of Vietnam?
Provide a short and direct response. -3.46e+06. In the year 1990, what is the difference between the Aid flow from UN agencies (US$) in Cambodia and Aid flow from UN agencies (US$) in Vietnam?
Your answer should be compact. -6.78e+06. In the year 1991, what is the difference between the Aid flow from UN agencies (US$) in Caribbean small states and Aid flow from UN agencies (US$) in Other small states?
Offer a very short reply. -6.30e+06. In the year 1991, what is the difference between the Aid flow from UN agencies (US$) of Caribbean small states and Aid flow from UN agencies (US$) of Cambodia?
Make the answer very short. -1.81e+07. In the year 1991, what is the difference between the Aid flow from UN agencies (US$) of Caribbean small states and Aid flow from UN agencies (US$) of Vietnam?
Ensure brevity in your answer.  -8.22e+06. In the year 1991, what is the difference between the Aid flow from UN agencies (US$) of Other small states and Aid flow from UN agencies (US$) of Cambodia?
Your answer should be very brief. -1.18e+07. In the year 1991, what is the difference between the Aid flow from UN agencies (US$) of Other small states and Aid flow from UN agencies (US$) of Vietnam?
Your answer should be compact. -1.92e+06. In the year 1991, what is the difference between the Aid flow from UN agencies (US$) of Cambodia and Aid flow from UN agencies (US$) of Vietnam?
Make the answer very short. 9.86e+06. In the year 1992, what is the difference between the Aid flow from UN agencies (US$) of Caribbean small states and Aid flow from UN agencies (US$) of Other small states?
Provide a short and direct response. -2.60e+06. In the year 1992, what is the difference between the Aid flow from UN agencies (US$) in Caribbean small states and Aid flow from UN agencies (US$) in Cambodia?
Give a very brief answer. -3.66e+07. In the year 1992, what is the difference between the Aid flow from UN agencies (US$) in Caribbean small states and Aid flow from UN agencies (US$) in Vietnam?
Offer a very short reply. -1.18e+07. In the year 1992, what is the difference between the Aid flow from UN agencies (US$) in Other small states and Aid flow from UN agencies (US$) in Cambodia?
Offer a terse response. -3.40e+07. In the year 1992, what is the difference between the Aid flow from UN agencies (US$) in Other small states and Aid flow from UN agencies (US$) in Vietnam?
Keep it short and to the point. -9.17e+06. In the year 1992, what is the difference between the Aid flow from UN agencies (US$) in Cambodia and Aid flow from UN agencies (US$) in Vietnam?
Offer a very short reply. 2.48e+07. In the year 1993, what is the difference between the Aid flow from UN agencies (US$) of Caribbean small states and Aid flow from UN agencies (US$) of Other small states?
Your answer should be very brief. -7.87e+06. In the year 1993, what is the difference between the Aid flow from UN agencies (US$) of Caribbean small states and Aid flow from UN agencies (US$) of Cambodia?
Ensure brevity in your answer.  -2.30e+07. In the year 1993, what is the difference between the Aid flow from UN agencies (US$) in Caribbean small states and Aid flow from UN agencies (US$) in Vietnam?
Offer a very short reply. -1.22e+07. In the year 1993, what is the difference between the Aid flow from UN agencies (US$) in Other small states and Aid flow from UN agencies (US$) in Cambodia?
Make the answer very short. -1.52e+07. In the year 1993, what is the difference between the Aid flow from UN agencies (US$) of Other small states and Aid flow from UN agencies (US$) of Vietnam?
Your answer should be compact. -4.36e+06. In the year 1993, what is the difference between the Aid flow from UN agencies (US$) in Cambodia and Aid flow from UN agencies (US$) in Vietnam?
Ensure brevity in your answer.  1.08e+07. What is the ratio of the Aid flow from UN agencies (US$) in Other small states in 1983 to that in 1984?
Your answer should be compact. 1.12. What is the ratio of the Aid flow from UN agencies (US$) in Cambodia in 1983 to that in 1984?
Your response must be concise. 0.44. What is the ratio of the Aid flow from UN agencies (US$) of Vietnam in 1983 to that in 1984?
Offer a very short reply. 1.18. What is the ratio of the Aid flow from UN agencies (US$) of Caribbean small states in 1983 to that in 1985?
Your response must be concise. 2.5. What is the ratio of the Aid flow from UN agencies (US$) in Other small states in 1983 to that in 1985?
Offer a very short reply. 1.28. What is the ratio of the Aid flow from UN agencies (US$) in Cambodia in 1983 to that in 1985?
Keep it short and to the point. 1.43. What is the ratio of the Aid flow from UN agencies (US$) of Vietnam in 1983 to that in 1985?
Make the answer very short. 1.29. What is the ratio of the Aid flow from UN agencies (US$) in Caribbean small states in 1983 to that in 1989?
Give a very brief answer. 0.15. What is the ratio of the Aid flow from UN agencies (US$) of Other small states in 1983 to that in 1989?
Your answer should be very brief. 0.42. What is the ratio of the Aid flow from UN agencies (US$) of Cambodia in 1983 to that in 1989?
Provide a short and direct response. 1.79. What is the ratio of the Aid flow from UN agencies (US$) of Vietnam in 1983 to that in 1989?
Your answer should be very brief. 0.86. What is the ratio of the Aid flow from UN agencies (US$) in Caribbean small states in 1983 to that in 1990?
Provide a succinct answer. 0.09. What is the ratio of the Aid flow from UN agencies (US$) in Other small states in 1983 to that in 1990?
Your answer should be very brief. 1.51. What is the ratio of the Aid flow from UN agencies (US$) in Cambodia in 1983 to that in 1990?
Offer a terse response. 1.04. What is the ratio of the Aid flow from UN agencies (US$) in Vietnam in 1983 to that in 1990?
Keep it short and to the point. 0.49. What is the ratio of the Aid flow from UN agencies (US$) of Caribbean small states in 1983 to that in 1991?
Your answer should be compact. 0.06. What is the ratio of the Aid flow from UN agencies (US$) in Other small states in 1983 to that in 1991?
Keep it short and to the point. 0.9. What is the ratio of the Aid flow from UN agencies (US$) of Cambodia in 1983 to that in 1991?
Ensure brevity in your answer.  0.05. What is the ratio of the Aid flow from UN agencies (US$) of Vietnam in 1983 to that in 1991?
Provide a succinct answer. 0.42. What is the ratio of the Aid flow from UN agencies (US$) in Caribbean small states in 1983 to that in 1992?
Your answer should be very brief. 0.02. What is the ratio of the Aid flow from UN agencies (US$) of Other small states in 1983 to that in 1992?
Ensure brevity in your answer.  1.11. What is the ratio of the Aid flow from UN agencies (US$) of Cambodia in 1983 to that in 1992?
Offer a very short reply. 0.03. What is the ratio of the Aid flow from UN agencies (US$) of Vietnam in 1983 to that in 1992?
Offer a terse response. 0.25. What is the ratio of the Aid flow from UN agencies (US$) in Caribbean small states in 1983 to that in 1993?
Give a very brief answer. 0.02. What is the ratio of the Aid flow from UN agencies (US$) of Other small states in 1983 to that in 1993?
Provide a short and direct response. 0.59. What is the ratio of the Aid flow from UN agencies (US$) in Cambodia in 1983 to that in 1993?
Give a very brief answer. 0.04. What is the ratio of the Aid flow from UN agencies (US$) of Vietnam in 1983 to that in 1993?
Keep it short and to the point. 0.25. What is the ratio of the Aid flow from UN agencies (US$) of Caribbean small states in 1984 to that in 1985?
Provide a succinct answer. 2. What is the ratio of the Aid flow from UN agencies (US$) in Other small states in 1984 to that in 1985?
Provide a short and direct response. 1.14. What is the ratio of the Aid flow from UN agencies (US$) of Cambodia in 1984 to that in 1985?
Your answer should be compact. 3.21. What is the ratio of the Aid flow from UN agencies (US$) of Vietnam in 1984 to that in 1985?
Ensure brevity in your answer.  1.09. What is the ratio of the Aid flow from UN agencies (US$) of Caribbean small states in 1984 to that in 1989?
Provide a succinct answer. 0.12. What is the ratio of the Aid flow from UN agencies (US$) of Other small states in 1984 to that in 1989?
Give a very brief answer. 0.37. What is the ratio of the Aid flow from UN agencies (US$) in Cambodia in 1984 to that in 1989?
Provide a short and direct response. 4.02. What is the ratio of the Aid flow from UN agencies (US$) of Vietnam in 1984 to that in 1989?
Ensure brevity in your answer.  0.73. What is the ratio of the Aid flow from UN agencies (US$) of Caribbean small states in 1984 to that in 1990?
Keep it short and to the point. 0.07. What is the ratio of the Aid flow from UN agencies (US$) in Other small states in 1984 to that in 1990?
Your answer should be compact. 1.35. What is the ratio of the Aid flow from UN agencies (US$) in Cambodia in 1984 to that in 1990?
Offer a very short reply. 2.34. What is the ratio of the Aid flow from UN agencies (US$) in Vietnam in 1984 to that in 1990?
Provide a succinct answer. 0.42. What is the ratio of the Aid flow from UN agencies (US$) of Caribbean small states in 1984 to that in 1991?
Ensure brevity in your answer.  0.05. What is the ratio of the Aid flow from UN agencies (US$) of Other small states in 1984 to that in 1991?
Make the answer very short. 0.8. What is the ratio of the Aid flow from UN agencies (US$) in Cambodia in 1984 to that in 1991?
Offer a terse response. 0.12. What is the ratio of the Aid flow from UN agencies (US$) of Vietnam in 1984 to that in 1991?
Keep it short and to the point. 0.35. What is the ratio of the Aid flow from UN agencies (US$) in Caribbean small states in 1984 to that in 1992?
Make the answer very short. 0.01. What is the ratio of the Aid flow from UN agencies (US$) of Cambodia in 1984 to that in 1992?
Make the answer very short. 0.06. What is the ratio of the Aid flow from UN agencies (US$) in Vietnam in 1984 to that in 1992?
Keep it short and to the point. 0.22. What is the ratio of the Aid flow from UN agencies (US$) in Caribbean small states in 1984 to that in 1993?
Provide a succinct answer. 0.01. What is the ratio of the Aid flow from UN agencies (US$) in Other small states in 1984 to that in 1993?
Make the answer very short. 0.52. What is the ratio of the Aid flow from UN agencies (US$) of Cambodia in 1984 to that in 1993?
Give a very brief answer. 0.09. What is the ratio of the Aid flow from UN agencies (US$) in Vietnam in 1984 to that in 1993?
Provide a succinct answer. 0.21. What is the ratio of the Aid flow from UN agencies (US$) in Caribbean small states in 1985 to that in 1989?
Offer a very short reply. 0.06. What is the ratio of the Aid flow from UN agencies (US$) of Other small states in 1985 to that in 1989?
Keep it short and to the point. 0.33. What is the ratio of the Aid flow from UN agencies (US$) of Cambodia in 1985 to that in 1989?
Your response must be concise. 1.25. What is the ratio of the Aid flow from UN agencies (US$) in Vietnam in 1985 to that in 1989?
Offer a very short reply. 0.67. What is the ratio of the Aid flow from UN agencies (US$) of Caribbean small states in 1985 to that in 1990?
Provide a short and direct response. 0.04. What is the ratio of the Aid flow from UN agencies (US$) in Other small states in 1985 to that in 1990?
Your answer should be very brief. 1.18. What is the ratio of the Aid flow from UN agencies (US$) in Cambodia in 1985 to that in 1990?
Give a very brief answer. 0.73. What is the ratio of the Aid flow from UN agencies (US$) of Vietnam in 1985 to that in 1990?
Offer a terse response. 0.38. What is the ratio of the Aid flow from UN agencies (US$) of Caribbean small states in 1985 to that in 1991?
Your answer should be compact. 0.02. What is the ratio of the Aid flow from UN agencies (US$) in Other small states in 1985 to that in 1991?
Provide a short and direct response. 0.7. What is the ratio of the Aid flow from UN agencies (US$) in Cambodia in 1985 to that in 1991?
Offer a terse response. 0.04. What is the ratio of the Aid flow from UN agencies (US$) in Vietnam in 1985 to that in 1991?
Give a very brief answer. 0.33. What is the ratio of the Aid flow from UN agencies (US$) in Caribbean small states in 1985 to that in 1992?
Your response must be concise. 0.01. What is the ratio of the Aid flow from UN agencies (US$) in Other small states in 1985 to that in 1992?
Offer a terse response. 0.86. What is the ratio of the Aid flow from UN agencies (US$) in Cambodia in 1985 to that in 1992?
Your response must be concise. 0.02. What is the ratio of the Aid flow from UN agencies (US$) of Vietnam in 1985 to that in 1992?
Keep it short and to the point. 0.2. What is the ratio of the Aid flow from UN agencies (US$) of Caribbean small states in 1985 to that in 1993?
Keep it short and to the point. 0.01. What is the ratio of the Aid flow from UN agencies (US$) in Other small states in 1985 to that in 1993?
Provide a succinct answer. 0.46. What is the ratio of the Aid flow from UN agencies (US$) in Cambodia in 1985 to that in 1993?
Give a very brief answer. 0.03. What is the ratio of the Aid flow from UN agencies (US$) of Vietnam in 1985 to that in 1993?
Give a very brief answer. 0.19. What is the ratio of the Aid flow from UN agencies (US$) in Caribbean small states in 1989 to that in 1990?
Give a very brief answer. 0.59. What is the ratio of the Aid flow from UN agencies (US$) in Other small states in 1989 to that in 1990?
Offer a very short reply. 3.61. What is the ratio of the Aid flow from UN agencies (US$) in Cambodia in 1989 to that in 1990?
Offer a terse response. 0.58. What is the ratio of the Aid flow from UN agencies (US$) in Vietnam in 1989 to that in 1990?
Give a very brief answer. 0.57. What is the ratio of the Aid flow from UN agencies (US$) in Caribbean small states in 1989 to that in 1991?
Keep it short and to the point. 0.38. What is the ratio of the Aid flow from UN agencies (US$) in Other small states in 1989 to that in 1991?
Ensure brevity in your answer.  2.15. What is the ratio of the Aid flow from UN agencies (US$) in Cambodia in 1989 to that in 1991?
Provide a short and direct response. 0.03. What is the ratio of the Aid flow from UN agencies (US$) in Vietnam in 1989 to that in 1991?
Keep it short and to the point. 0.49. What is the ratio of the Aid flow from UN agencies (US$) in Caribbean small states in 1989 to that in 1992?
Your answer should be compact. 0.1. What is the ratio of the Aid flow from UN agencies (US$) of Other small states in 1989 to that in 1992?
Provide a succinct answer. 2.64. What is the ratio of the Aid flow from UN agencies (US$) of Cambodia in 1989 to that in 1992?
Give a very brief answer. 0.01. What is the ratio of the Aid flow from UN agencies (US$) of Vietnam in 1989 to that in 1992?
Your answer should be very brief. 0.3. What is the ratio of the Aid flow from UN agencies (US$) in Caribbean small states in 1989 to that in 1993?
Offer a terse response. 0.1. What is the ratio of the Aid flow from UN agencies (US$) in Other small states in 1989 to that in 1993?
Offer a very short reply. 1.4. What is the ratio of the Aid flow from UN agencies (US$) in Cambodia in 1989 to that in 1993?
Your response must be concise. 0.02. What is the ratio of the Aid flow from UN agencies (US$) of Vietnam in 1989 to that in 1993?
Give a very brief answer. 0.29. What is the ratio of the Aid flow from UN agencies (US$) of Caribbean small states in 1990 to that in 1991?
Make the answer very short. 0.64. What is the ratio of the Aid flow from UN agencies (US$) in Other small states in 1990 to that in 1991?
Give a very brief answer. 0.6. What is the ratio of the Aid flow from UN agencies (US$) of Cambodia in 1990 to that in 1991?
Your response must be concise. 0.05. What is the ratio of the Aid flow from UN agencies (US$) of Vietnam in 1990 to that in 1991?
Make the answer very short. 0.85. What is the ratio of the Aid flow from UN agencies (US$) in Caribbean small states in 1990 to that in 1992?
Your answer should be very brief. 0.17. What is the ratio of the Aid flow from UN agencies (US$) in Other small states in 1990 to that in 1992?
Your answer should be compact. 0.73. What is the ratio of the Aid flow from UN agencies (US$) of Cambodia in 1990 to that in 1992?
Offer a terse response. 0.02. What is the ratio of the Aid flow from UN agencies (US$) of Vietnam in 1990 to that in 1992?
Give a very brief answer. 0.52. What is the ratio of the Aid flow from UN agencies (US$) of Caribbean small states in 1990 to that in 1993?
Offer a terse response. 0.18. What is the ratio of the Aid flow from UN agencies (US$) in Other small states in 1990 to that in 1993?
Give a very brief answer. 0.39. What is the ratio of the Aid flow from UN agencies (US$) of Cambodia in 1990 to that in 1993?
Your response must be concise. 0.04. What is the ratio of the Aid flow from UN agencies (US$) of Vietnam in 1990 to that in 1993?
Ensure brevity in your answer.  0.5. What is the ratio of the Aid flow from UN agencies (US$) in Caribbean small states in 1991 to that in 1992?
Your response must be concise. 0.27. What is the ratio of the Aid flow from UN agencies (US$) of Other small states in 1991 to that in 1992?
Ensure brevity in your answer.  1.23. What is the ratio of the Aid flow from UN agencies (US$) in Cambodia in 1991 to that in 1992?
Offer a very short reply. 0.48. What is the ratio of the Aid flow from UN agencies (US$) in Vietnam in 1991 to that in 1992?
Provide a succinct answer. 0.61. What is the ratio of the Aid flow from UN agencies (US$) in Caribbean small states in 1991 to that in 1993?
Keep it short and to the point. 0.28. What is the ratio of the Aid flow from UN agencies (US$) in Other small states in 1991 to that in 1993?
Give a very brief answer. 0.65. What is the ratio of the Aid flow from UN agencies (US$) of Cambodia in 1991 to that in 1993?
Ensure brevity in your answer.  0.72. What is the ratio of the Aid flow from UN agencies (US$) of Vietnam in 1991 to that in 1993?
Offer a terse response. 0.59. What is the ratio of the Aid flow from UN agencies (US$) of Caribbean small states in 1992 to that in 1993?
Offer a terse response. 1.02. What is the ratio of the Aid flow from UN agencies (US$) of Other small states in 1992 to that in 1993?
Make the answer very short. 0.53. What is the ratio of the Aid flow from UN agencies (US$) of Cambodia in 1992 to that in 1993?
Your answer should be very brief. 1.52. What is the ratio of the Aid flow from UN agencies (US$) in Vietnam in 1992 to that in 1993?
Offer a very short reply. 0.97. What is the difference between the highest and the second highest Aid flow from UN agencies (US$) of Caribbean small states?
Offer a very short reply. 7.00e+04. What is the difference between the highest and the second highest Aid flow from UN agencies (US$) in Other small states?
Keep it short and to the point. 4.40e+06. What is the difference between the highest and the second highest Aid flow from UN agencies (US$) in Cambodia?
Provide a succinct answer. 1.36e+07. What is the difference between the highest and the second highest Aid flow from UN agencies (US$) in Vietnam?
Keep it short and to the point. 3.90e+05. What is the difference between the highest and the lowest Aid flow from UN agencies (US$) in Caribbean small states?
Your answer should be very brief. 3.22e+06. What is the difference between the highest and the lowest Aid flow from UN agencies (US$) of Other small states?
Keep it short and to the point. 1.12e+07. What is the difference between the highest and the lowest Aid flow from UN agencies (US$) of Cambodia?
Offer a very short reply. 3.93e+07. What is the difference between the highest and the lowest Aid flow from UN agencies (US$) in Vietnam?
Your response must be concise. 1.24e+07. 